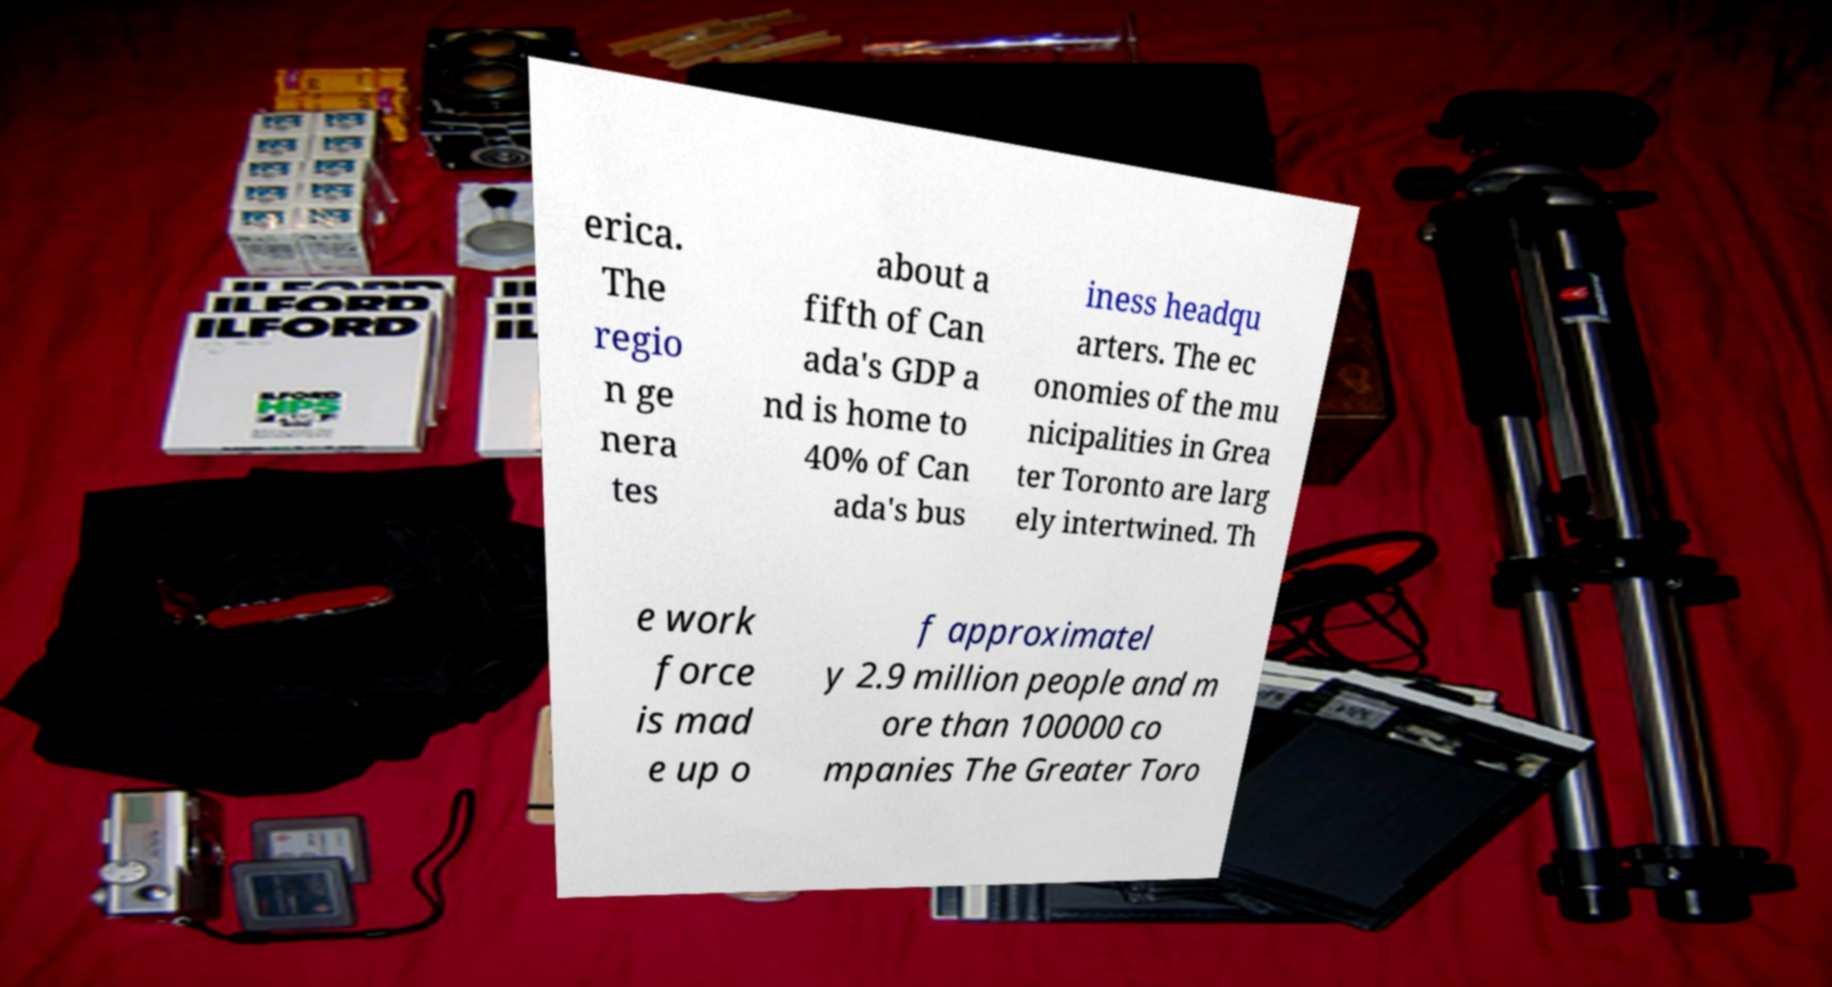Please identify and transcribe the text found in this image. erica. The regio n ge nera tes about a fifth of Can ada's GDP a nd is home to 40% of Can ada's bus iness headqu arters. The ec onomies of the mu nicipalities in Grea ter Toronto are larg ely intertwined. Th e work force is mad e up o f approximatel y 2.9 million people and m ore than 100000 co mpanies The Greater Toro 